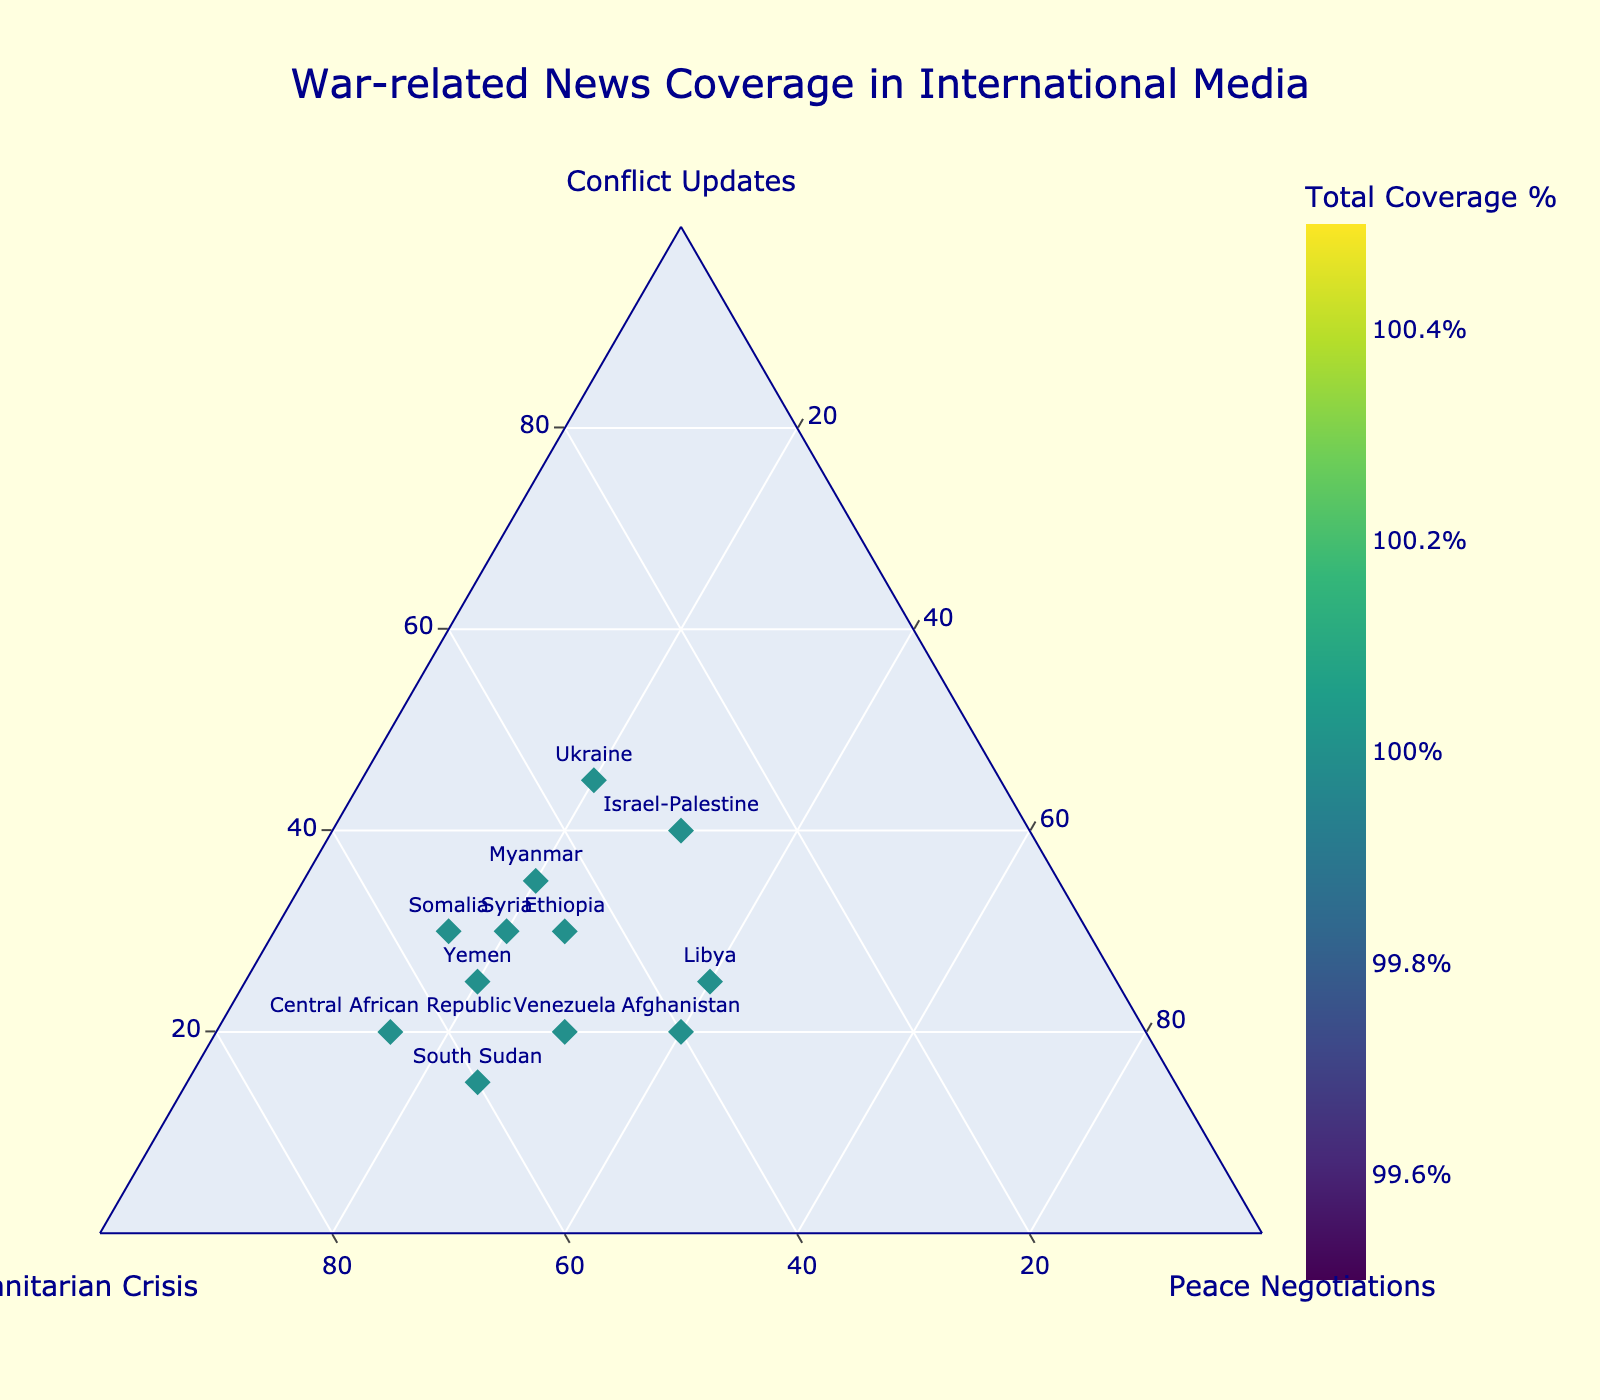What is the title of the ternary plot? The title of the plot is located at the top center of the figure and it is the largest text.
Answer: War-related News Coverage in International Media Which country has the highest proportion of coverage on the Humanitarian Crisis? By examining the vertical axis labeled "Humanitarian Crisis," the highest proportion corresponds to the Central African Republic.
Answer: Central African Republic What is the total percentage of news coverage for Libya? The data point marker's color indicates the total percentage, and the color bar on the right shows that for Libya, the total coverage is one of the highest values. By comparing colors, it matches the higher end of the scale, which indicates total coverage.
Answer: 100% Compare Ukraine and Syria in terms of Peace Negotiations' coverage. Which one has more percentage coverage? For Peace Negotiations, we look at the axis labeled "Peace Negotiations" and compare the values for both countries. Ukraine has 20% while Syria also has 20%, making them equal.
Answer: They are equal Which country has a more balanced coverage between Conflict Updates and Humanitarian Crisis? For a balanced coverage between Conflict Updates and Humanitarian Crisis, we look for countries whose points are closest to the center between these two axes. Israel-Palestine, lying more central, suggests a more balanced coverage between these two categories.
Answer: Israel-Palestine How does the international media coverage of Sudan compare to Venezuela regarding Humanitarian Crisis? On the vertical axis, compare the position of South Sudan and Venezuela. South Sudan is at 60%, while Venezuela is at 50%.
Answer: South Sudan has more Which country has the least coverage on Conflict Updates? Look at the bottom left axis labeled "Conflict Updates" to find the country with the smallest percentage. The country with the data point closest to 0 on this axis is the Central African Republic with 20%.
Answer: Central African Republic Among the countries listed, which one has the highest proportion of coverage for Peace Negotiations? Checking the axis labeled "Peace Negotiations" for the highest value, Libya has the highest proportion at 40%.
Answer: Libya 